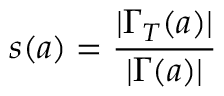<formula> <loc_0><loc_0><loc_500><loc_500>s ( a ) = \frac { | \Gamma _ { T } ( a ) | } { | \Gamma ( a ) | }</formula> 